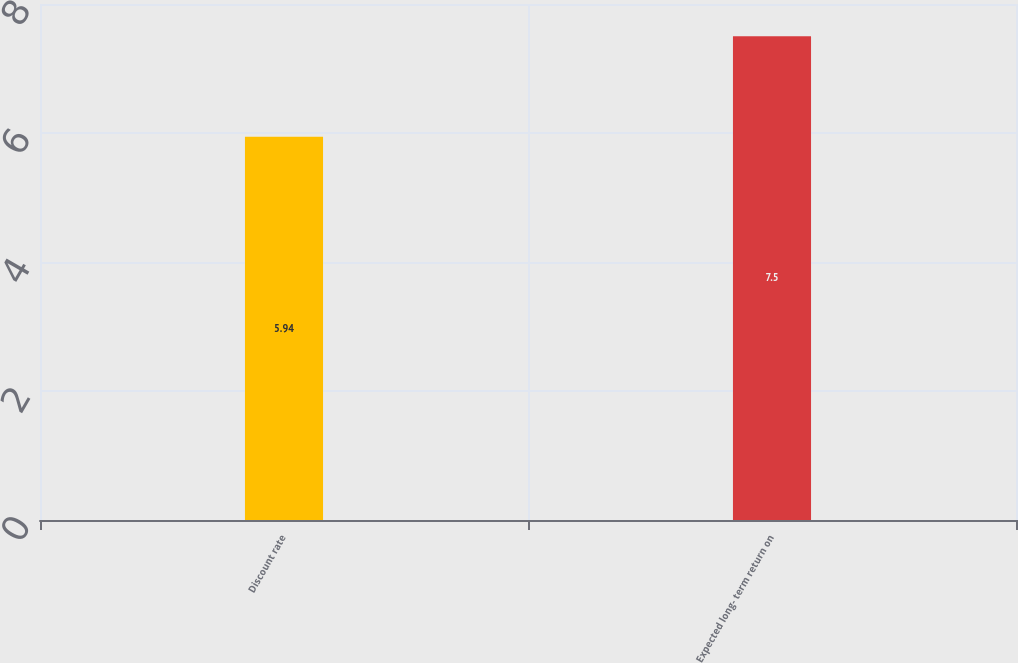<chart> <loc_0><loc_0><loc_500><loc_500><bar_chart><fcel>Discount rate<fcel>Expected long- term return on<nl><fcel>5.94<fcel>7.5<nl></chart> 